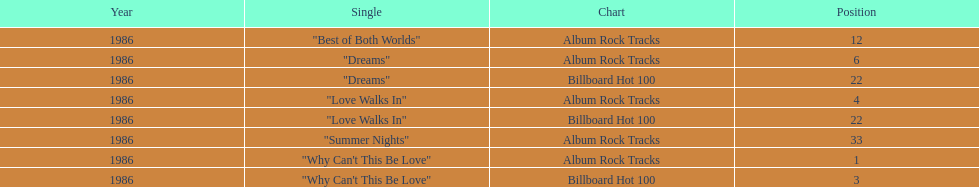What is the most prevalent single on the album? Why Can't This Be Love. 